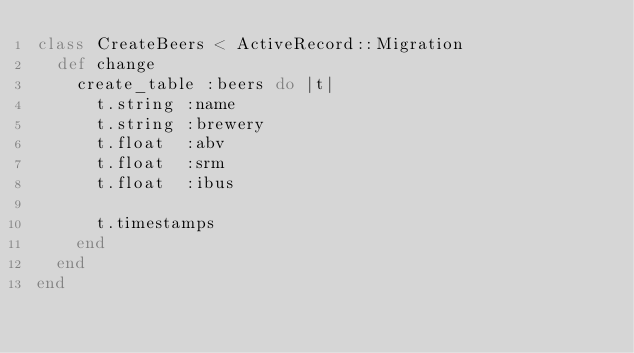<code> <loc_0><loc_0><loc_500><loc_500><_Ruby_>class CreateBeers < ActiveRecord::Migration
  def change
    create_table :beers do |t|
      t.string :name
      t.string :brewery
      t.float  :abv
      t.float  :srm
      t.float  :ibus

      t.timestamps
    end
  end
end
</code> 